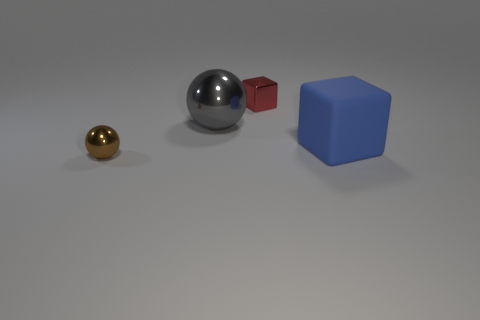What is the material of the blue block?
Give a very brief answer. Rubber. How many other things are there of the same material as the small block?
Ensure brevity in your answer.  2. How many large blocks are there?
Ensure brevity in your answer.  1. There is another object that is the same shape as the tiny brown metallic thing; what is it made of?
Provide a succinct answer. Metal. Does the sphere in front of the gray metal ball have the same material as the large ball?
Keep it short and to the point. Yes. Are there more large blue rubber things that are on the right side of the red thing than small metallic blocks that are in front of the gray sphere?
Keep it short and to the point. Yes. How big is the gray metallic ball?
Ensure brevity in your answer.  Large. There is a big thing that is the same material as the small block; what shape is it?
Make the answer very short. Sphere. Do the object that is in front of the blue rubber object and the large blue matte thing have the same shape?
Keep it short and to the point. No. What number of objects are either brown balls or big blue cubes?
Make the answer very short. 2. 